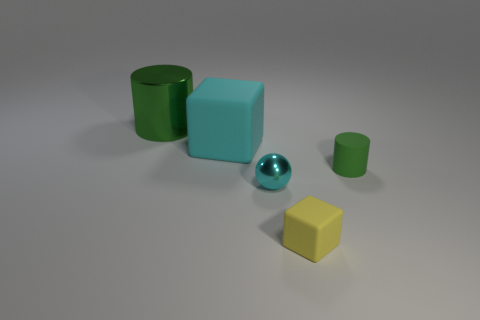How many other objects are the same shape as the cyan rubber thing?
Provide a succinct answer. 1. Are there an equal number of cyan rubber cubes that are behind the cyan matte cube and large cyan cubes that are to the right of the tiny green rubber thing?
Keep it short and to the point. Yes. What is the big cyan block made of?
Ensure brevity in your answer.  Rubber. What is the cylinder that is on the right side of the tiny yellow matte cube made of?
Your response must be concise. Rubber. Are there any other things that are made of the same material as the small cylinder?
Offer a very short reply. Yes. Is the number of yellow blocks to the left of the tiny cyan sphere greater than the number of cyan cylinders?
Offer a terse response. No. There is a tiny metal ball that is left of the rubber thing that is in front of the small matte cylinder; are there any tiny cylinders that are on the right side of it?
Your answer should be very brief. Yes. There is a green metallic thing; are there any tiny things behind it?
Offer a terse response. No. What number of metallic things are the same color as the shiny cylinder?
Your response must be concise. 0. There is a cyan object that is the same material as the tiny green thing; what size is it?
Offer a very short reply. Large. 